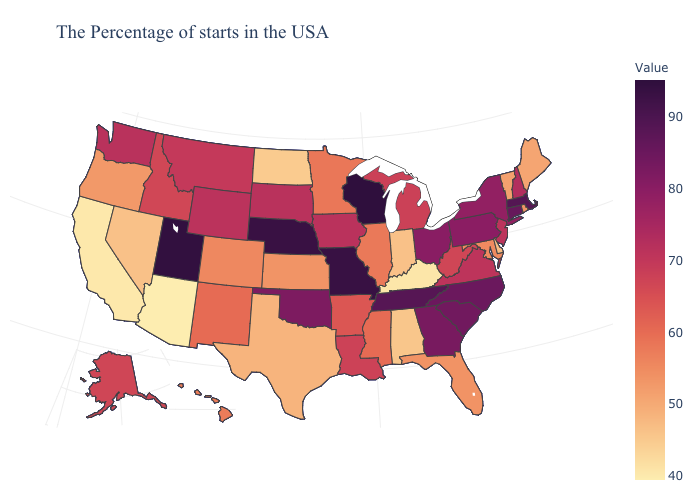Which states have the lowest value in the MidWest?
Be succinct. North Dakota. Does Arizona have the lowest value in the USA?
Give a very brief answer. Yes. Does Virginia have a lower value than Indiana?
Be succinct. No. Does Arizona have a higher value than New Jersey?
Keep it brief. No. Does Maryland have a higher value than Alabama?
Write a very short answer. Yes. Among the states that border Wyoming , does Colorado have the lowest value?
Write a very short answer. Yes. 